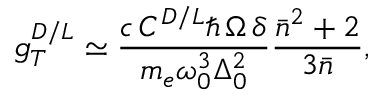Convert formula to latex. <formula><loc_0><loc_0><loc_500><loc_500>g _ { T } ^ { D / L } \simeq \frac { c \, C ^ { D / L } \hbar { \, } \Omega \, \delta } { m _ { e } \omega _ { 0 } ^ { 3 } \Delta _ { 0 } ^ { 2 } } \frac { \bar { n } ^ { 2 } + 2 } { 3 \bar { n } } ,</formula> 